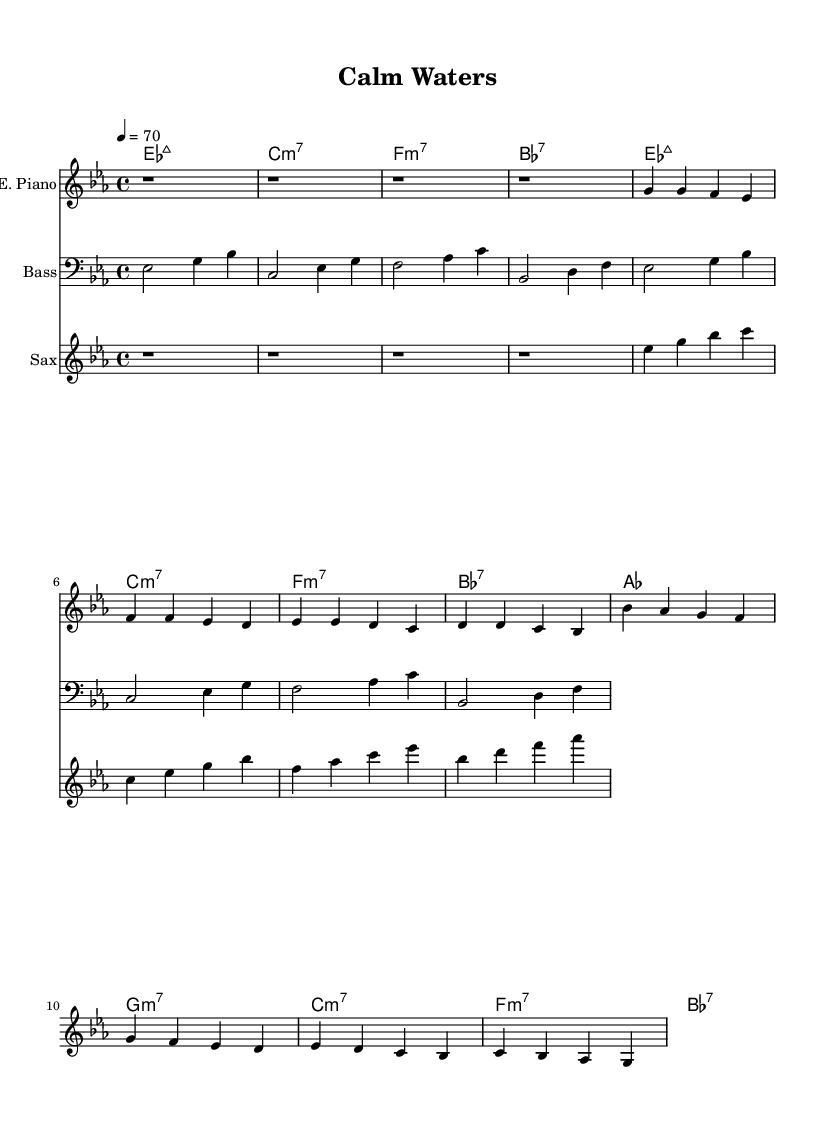What is the key signature of this music? The key signature is Es major, which has three flats (B, E, and A). This is indicated at the beginning of the score.
Answer: Es major What is the time signature of this music? The time signature is 4/4, meaning there are four beats per measure. This is indicated in the first measure of the score.
Answer: 4/4 What is the tempo marking of the piece? The tempo marking indicates a speed of 70 beats per minute, specified at the start of the score as "4 = 70."
Answer: 70 How many measures are in the chorus section? The chorus section consists of four measures as evident by looking at the repeated structure of the chords and notes in the chorus part.
Answer: 4 Identify the first chord in the piece. The first chord notation is Es major 7, written at the beginning of the score, and it sets a relaxed tone for the piece.
Answer: Es major 7 Describe the instrumentation used in this piece. The piece features three instruments: electric piano, bass guitar, and saxophone, indicated by the labels at the beginning of each staff.
Answer: Electric piano, bass guitar, saxophone What defines the style of this music as Rhythm and Blues? The combination of the laid-back tempo, smooth soulful melodies, and use of extended chords (like major 7 and minor 7) are characteristic of Rhythm and Blues.
Answer: Relaxed tempo, soulful melodies 